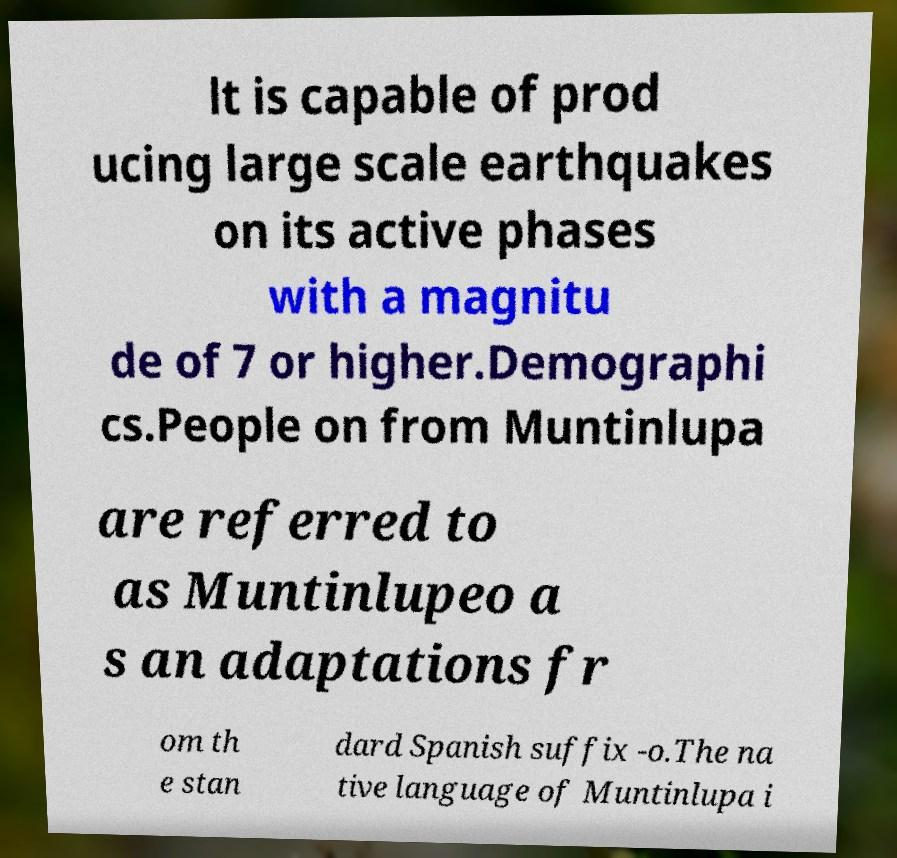Could you extract and type out the text from this image? lt is capable of prod ucing large scale earthquakes on its active phases with a magnitu de of 7 or higher.Demographi cs.People on from Muntinlupa are referred to as Muntinlupeo a s an adaptations fr om th e stan dard Spanish suffix -o.The na tive language of Muntinlupa i 